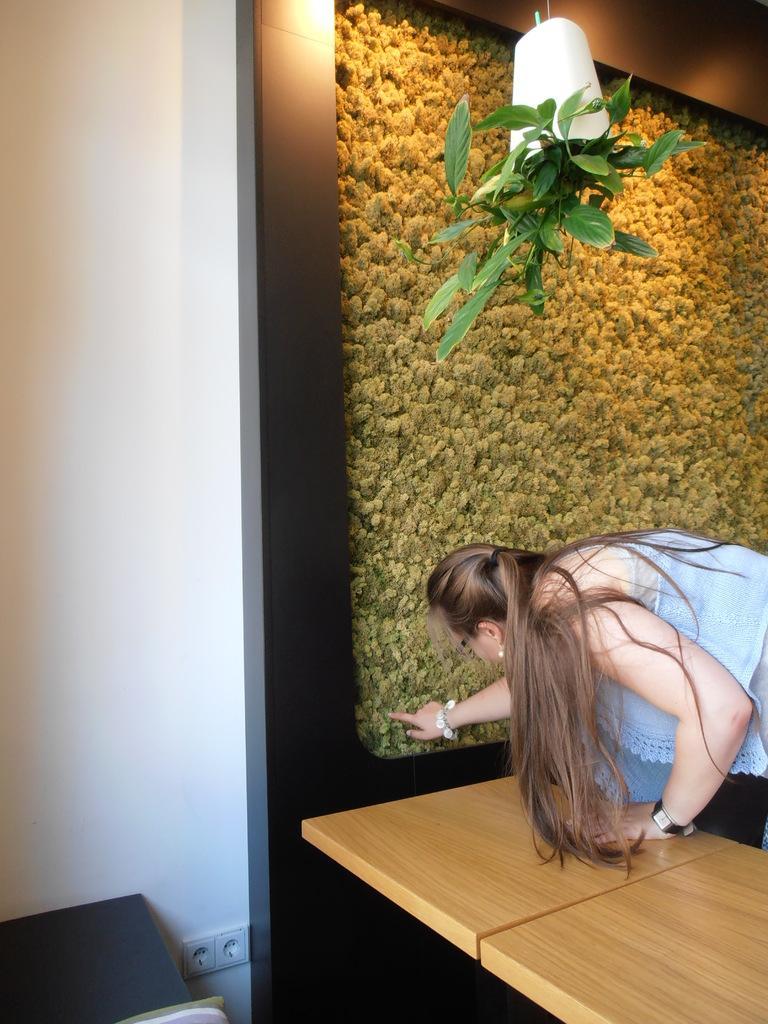Please provide a concise description of this image. In the right corner we can see one lady in front of her there is a table. Coming to the background we can see the wall and pot. 